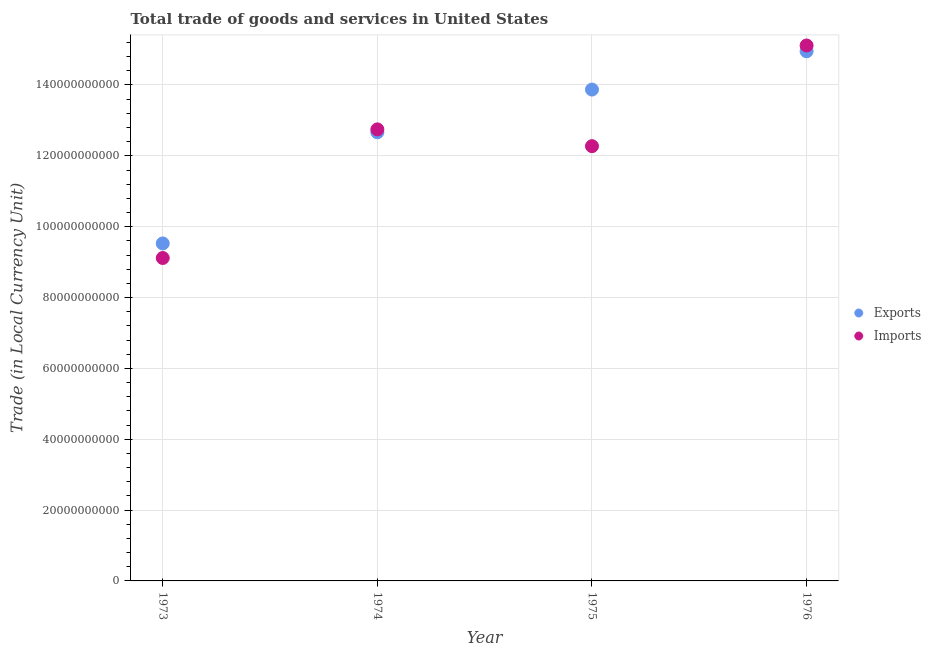How many different coloured dotlines are there?
Your answer should be compact. 2. Is the number of dotlines equal to the number of legend labels?
Offer a terse response. Yes. What is the export of goods and services in 1976?
Provide a succinct answer. 1.50e+11. Across all years, what is the maximum imports of goods and services?
Provide a short and direct response. 1.51e+11. Across all years, what is the minimum export of goods and services?
Ensure brevity in your answer.  9.53e+1. In which year was the imports of goods and services maximum?
Your answer should be compact. 1976. In which year was the imports of goods and services minimum?
Give a very brief answer. 1973. What is the total imports of goods and services in the graph?
Ensure brevity in your answer.  4.92e+11. What is the difference between the imports of goods and services in 1974 and that in 1976?
Keep it short and to the point. -2.37e+1. What is the difference between the imports of goods and services in 1974 and the export of goods and services in 1976?
Ensure brevity in your answer.  -2.20e+1. What is the average imports of goods and services per year?
Keep it short and to the point. 1.23e+11. In the year 1975, what is the difference between the imports of goods and services and export of goods and services?
Ensure brevity in your answer.  -1.60e+1. In how many years, is the imports of goods and services greater than 8000000000 LCU?
Your answer should be compact. 4. What is the ratio of the imports of goods and services in 1974 to that in 1975?
Give a very brief answer. 1.04. What is the difference between the highest and the second highest imports of goods and services?
Your answer should be very brief. 2.37e+1. What is the difference between the highest and the lowest imports of goods and services?
Your response must be concise. 6.00e+1. Is the export of goods and services strictly greater than the imports of goods and services over the years?
Offer a terse response. No. Is the export of goods and services strictly less than the imports of goods and services over the years?
Give a very brief answer. No. Does the graph contain grids?
Your answer should be compact. Yes. Where does the legend appear in the graph?
Your response must be concise. Center right. How are the legend labels stacked?
Your response must be concise. Vertical. What is the title of the graph?
Ensure brevity in your answer.  Total trade of goods and services in United States. What is the label or title of the Y-axis?
Offer a very short reply. Trade (in Local Currency Unit). What is the Trade (in Local Currency Unit) of Exports in 1973?
Your answer should be compact. 9.53e+1. What is the Trade (in Local Currency Unit) of Imports in 1973?
Offer a very short reply. 9.12e+1. What is the Trade (in Local Currency Unit) of Exports in 1974?
Provide a succinct answer. 1.27e+11. What is the Trade (in Local Currency Unit) in Imports in 1974?
Offer a terse response. 1.27e+11. What is the Trade (in Local Currency Unit) of Exports in 1975?
Ensure brevity in your answer.  1.39e+11. What is the Trade (in Local Currency Unit) in Imports in 1975?
Your response must be concise. 1.23e+11. What is the Trade (in Local Currency Unit) in Exports in 1976?
Keep it short and to the point. 1.50e+11. What is the Trade (in Local Currency Unit) in Imports in 1976?
Make the answer very short. 1.51e+11. Across all years, what is the maximum Trade (in Local Currency Unit) of Exports?
Your response must be concise. 1.50e+11. Across all years, what is the maximum Trade (in Local Currency Unit) of Imports?
Offer a very short reply. 1.51e+11. Across all years, what is the minimum Trade (in Local Currency Unit) of Exports?
Offer a terse response. 9.53e+1. Across all years, what is the minimum Trade (in Local Currency Unit) in Imports?
Offer a very short reply. 9.12e+1. What is the total Trade (in Local Currency Unit) in Exports in the graph?
Offer a very short reply. 5.10e+11. What is the total Trade (in Local Currency Unit) of Imports in the graph?
Give a very brief answer. 4.92e+11. What is the difference between the Trade (in Local Currency Unit) in Exports in 1973 and that in 1974?
Your answer should be very brief. -3.14e+1. What is the difference between the Trade (in Local Currency Unit) of Imports in 1973 and that in 1974?
Keep it short and to the point. -3.63e+1. What is the difference between the Trade (in Local Currency Unit) of Exports in 1973 and that in 1975?
Offer a very short reply. -4.34e+1. What is the difference between the Trade (in Local Currency Unit) in Imports in 1973 and that in 1975?
Provide a succinct answer. -3.16e+1. What is the difference between the Trade (in Local Currency Unit) of Exports in 1973 and that in 1976?
Offer a very short reply. -5.42e+1. What is the difference between the Trade (in Local Currency Unit) in Imports in 1973 and that in 1976?
Make the answer very short. -6.00e+1. What is the difference between the Trade (in Local Currency Unit) of Exports in 1974 and that in 1975?
Provide a short and direct response. -1.21e+1. What is the difference between the Trade (in Local Currency Unit) in Imports in 1974 and that in 1975?
Provide a succinct answer. 4.74e+09. What is the difference between the Trade (in Local Currency Unit) in Exports in 1974 and that in 1976?
Provide a short and direct response. -2.29e+1. What is the difference between the Trade (in Local Currency Unit) in Imports in 1974 and that in 1976?
Make the answer very short. -2.37e+1. What is the difference between the Trade (in Local Currency Unit) in Exports in 1975 and that in 1976?
Ensure brevity in your answer.  -1.08e+1. What is the difference between the Trade (in Local Currency Unit) in Imports in 1975 and that in 1976?
Make the answer very short. -2.84e+1. What is the difference between the Trade (in Local Currency Unit) of Exports in 1973 and the Trade (in Local Currency Unit) of Imports in 1974?
Your answer should be compact. -3.22e+1. What is the difference between the Trade (in Local Currency Unit) of Exports in 1973 and the Trade (in Local Currency Unit) of Imports in 1975?
Keep it short and to the point. -2.75e+1. What is the difference between the Trade (in Local Currency Unit) of Exports in 1973 and the Trade (in Local Currency Unit) of Imports in 1976?
Ensure brevity in your answer.  -5.59e+1. What is the difference between the Trade (in Local Currency Unit) of Exports in 1974 and the Trade (in Local Currency Unit) of Imports in 1975?
Provide a succinct answer. 3.92e+09. What is the difference between the Trade (in Local Currency Unit) in Exports in 1974 and the Trade (in Local Currency Unit) in Imports in 1976?
Keep it short and to the point. -2.45e+1. What is the difference between the Trade (in Local Currency Unit) in Exports in 1975 and the Trade (in Local Currency Unit) in Imports in 1976?
Make the answer very short. -1.24e+1. What is the average Trade (in Local Currency Unit) of Exports per year?
Give a very brief answer. 1.28e+11. What is the average Trade (in Local Currency Unit) in Imports per year?
Your answer should be very brief. 1.23e+11. In the year 1973, what is the difference between the Trade (in Local Currency Unit) in Exports and Trade (in Local Currency Unit) in Imports?
Make the answer very short. 4.11e+09. In the year 1974, what is the difference between the Trade (in Local Currency Unit) of Exports and Trade (in Local Currency Unit) of Imports?
Your answer should be compact. -8.14e+08. In the year 1975, what is the difference between the Trade (in Local Currency Unit) in Exports and Trade (in Local Currency Unit) in Imports?
Offer a terse response. 1.60e+1. In the year 1976, what is the difference between the Trade (in Local Currency Unit) of Exports and Trade (in Local Currency Unit) of Imports?
Ensure brevity in your answer.  -1.63e+09. What is the ratio of the Trade (in Local Currency Unit) of Exports in 1973 to that in 1974?
Give a very brief answer. 0.75. What is the ratio of the Trade (in Local Currency Unit) in Imports in 1973 to that in 1974?
Your response must be concise. 0.72. What is the ratio of the Trade (in Local Currency Unit) of Exports in 1973 to that in 1975?
Your answer should be very brief. 0.69. What is the ratio of the Trade (in Local Currency Unit) of Imports in 1973 to that in 1975?
Keep it short and to the point. 0.74. What is the ratio of the Trade (in Local Currency Unit) in Exports in 1973 to that in 1976?
Offer a very short reply. 0.64. What is the ratio of the Trade (in Local Currency Unit) in Imports in 1973 to that in 1976?
Make the answer very short. 0.6. What is the ratio of the Trade (in Local Currency Unit) of Exports in 1974 to that in 1975?
Give a very brief answer. 0.91. What is the ratio of the Trade (in Local Currency Unit) of Imports in 1974 to that in 1975?
Your answer should be very brief. 1.04. What is the ratio of the Trade (in Local Currency Unit) in Exports in 1974 to that in 1976?
Provide a short and direct response. 0.85. What is the ratio of the Trade (in Local Currency Unit) in Imports in 1974 to that in 1976?
Your answer should be very brief. 0.84. What is the ratio of the Trade (in Local Currency Unit) of Exports in 1975 to that in 1976?
Your answer should be compact. 0.93. What is the ratio of the Trade (in Local Currency Unit) in Imports in 1975 to that in 1976?
Your answer should be very brief. 0.81. What is the difference between the highest and the second highest Trade (in Local Currency Unit) in Exports?
Your answer should be very brief. 1.08e+1. What is the difference between the highest and the second highest Trade (in Local Currency Unit) in Imports?
Your answer should be very brief. 2.37e+1. What is the difference between the highest and the lowest Trade (in Local Currency Unit) in Exports?
Your answer should be compact. 5.42e+1. What is the difference between the highest and the lowest Trade (in Local Currency Unit) in Imports?
Offer a terse response. 6.00e+1. 